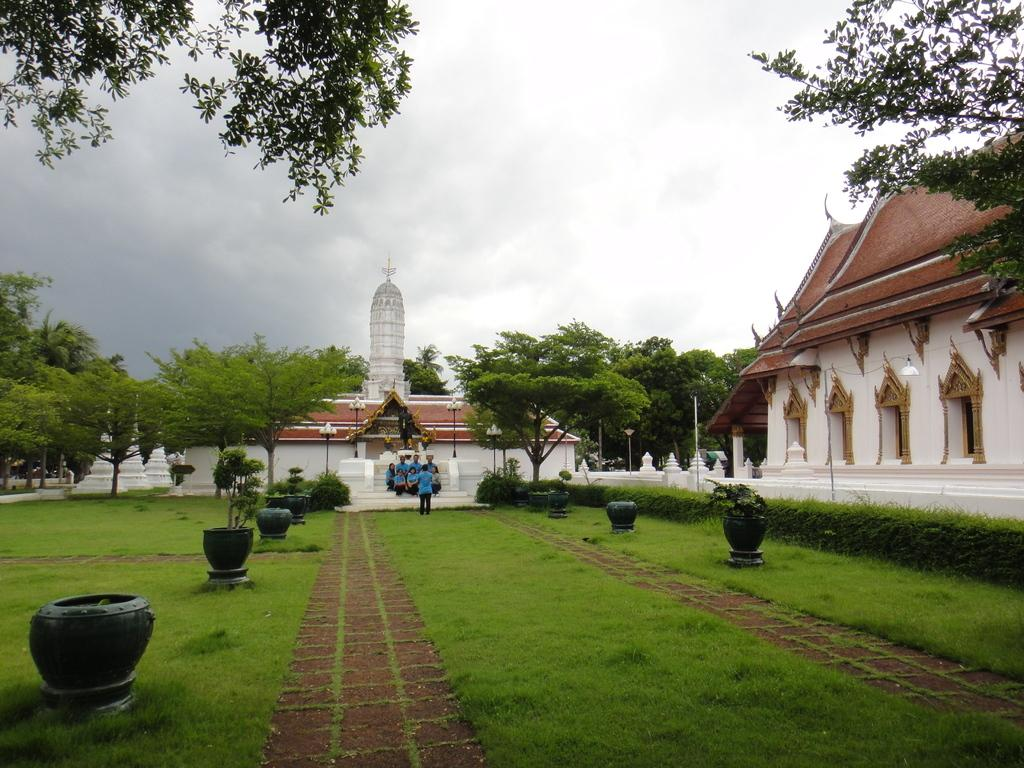What are the people in the image doing? There are persons sitting on the steps in the image. How many buildings can be seen in the image? There are two buildings visible in the image. What type of vegetation is present in the image? There are trees, plants, and grass in the image. What is visible in the sky at the top of the image? Clouds are visible in the sky at the top of the image. What time of day is it in the image, and how does the mind of the person sitting on the steps feel? The provided facts do not give information about the time of day or the person's mind, so we cannot answer these questions based on the image. 